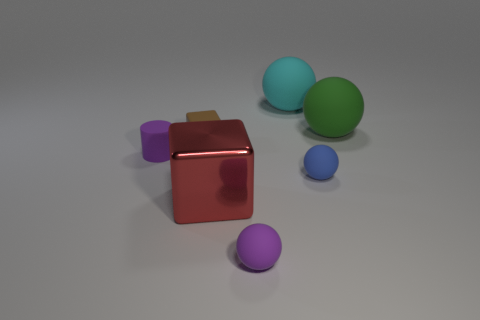Subtract all big green balls. How many balls are left? 3 Add 3 red blocks. How many objects exist? 10 Subtract all balls. How many objects are left? 3 Subtract 1 cubes. How many cubes are left? 1 Subtract all cyan spheres. How many spheres are left? 3 Add 4 big yellow things. How many big yellow things exist? 4 Subtract 1 brown cubes. How many objects are left? 6 Subtract all brown cylinders. Subtract all cyan cubes. How many cylinders are left? 1 Subtract all tiny matte objects. Subtract all rubber blocks. How many objects are left? 2 Add 2 tiny rubber spheres. How many tiny rubber spheres are left? 4 